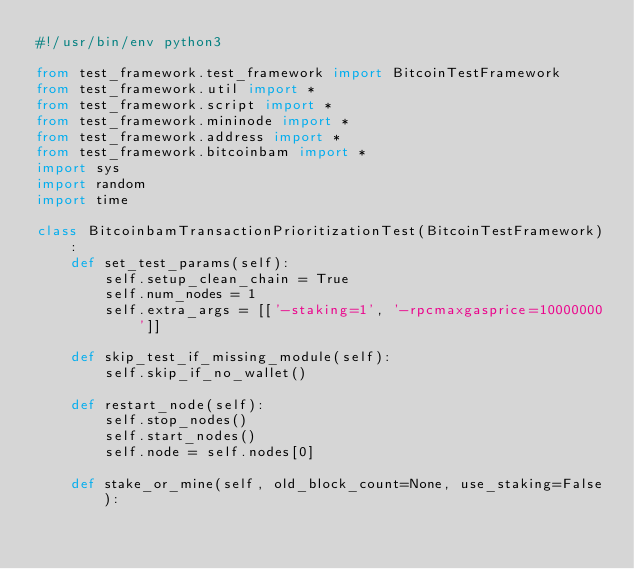Convert code to text. <code><loc_0><loc_0><loc_500><loc_500><_Python_>#!/usr/bin/env python3

from test_framework.test_framework import BitcoinTestFramework
from test_framework.util import *
from test_framework.script import *
from test_framework.mininode import *
from test_framework.address import *
from test_framework.bitcoinbam import *
import sys
import random
import time

class BitcoinbamTransactionPrioritizationTest(BitcoinTestFramework):
    def set_test_params(self):
        self.setup_clean_chain = True
        self.num_nodes = 1
        self.extra_args = [['-staking=1', '-rpcmaxgasprice=10000000']]

    def skip_test_if_missing_module(self):
        self.skip_if_no_wallet()

    def restart_node(self):
        self.stop_nodes()
        self.start_nodes()
        self.node = self.nodes[0]

    def stake_or_mine(self, old_block_count=None, use_staking=False):</code> 